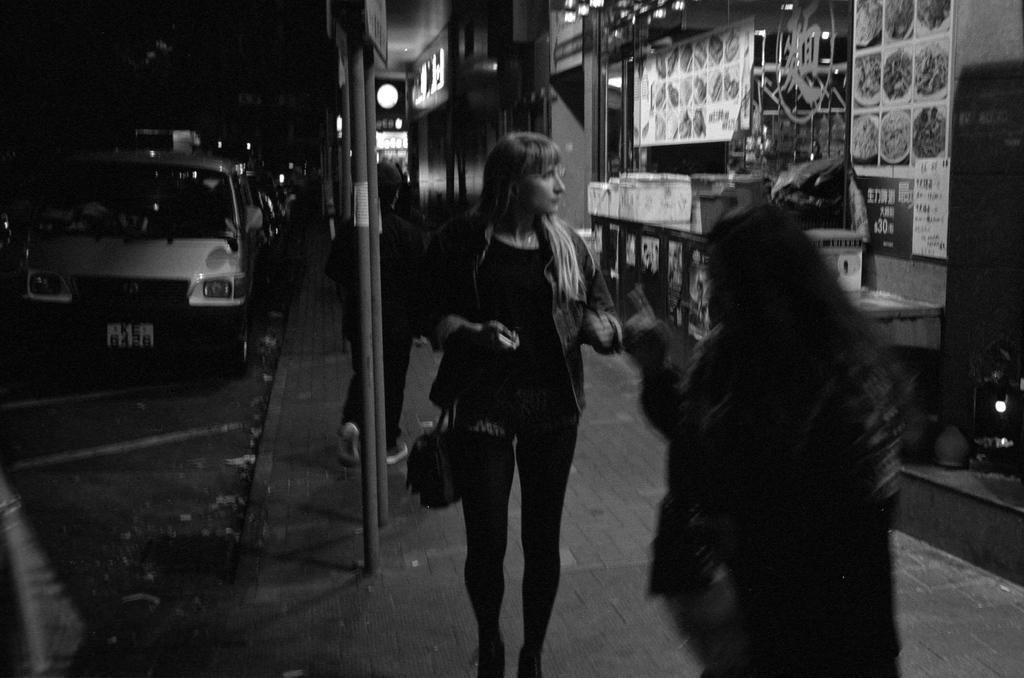In one or two sentences, can you explain what this image depicts? This is a black and white image. On the left side there are vehicles. Also there is a sidewalk. And there are few people on the sidewalk. There are poles. On the right side there are buildings. On the wall there are boards with something written and some images are there. 